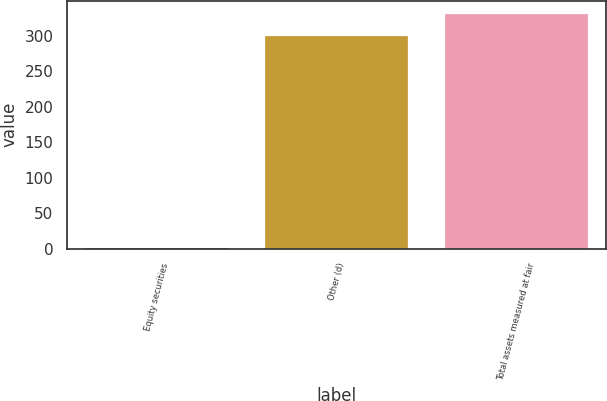Convert chart to OTSL. <chart><loc_0><loc_0><loc_500><loc_500><bar_chart><fcel>Equity securities<fcel>Other (d)<fcel>Total assets measured at fair<nl><fcel>2<fcel>302<fcel>332.8<nl></chart> 